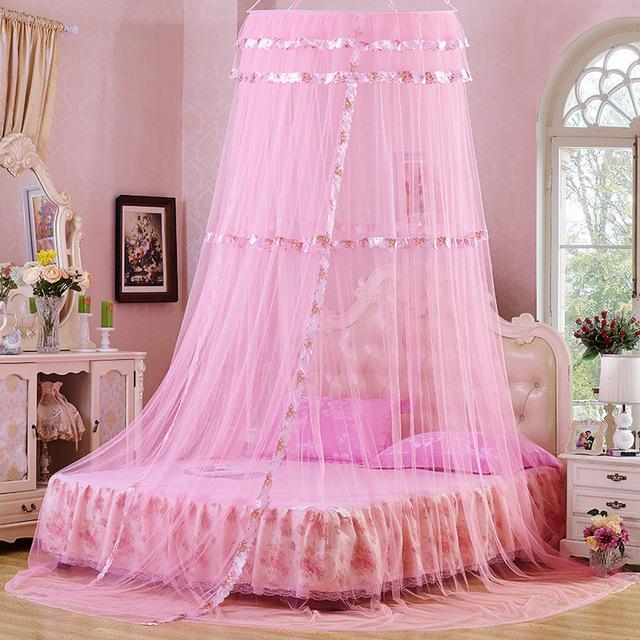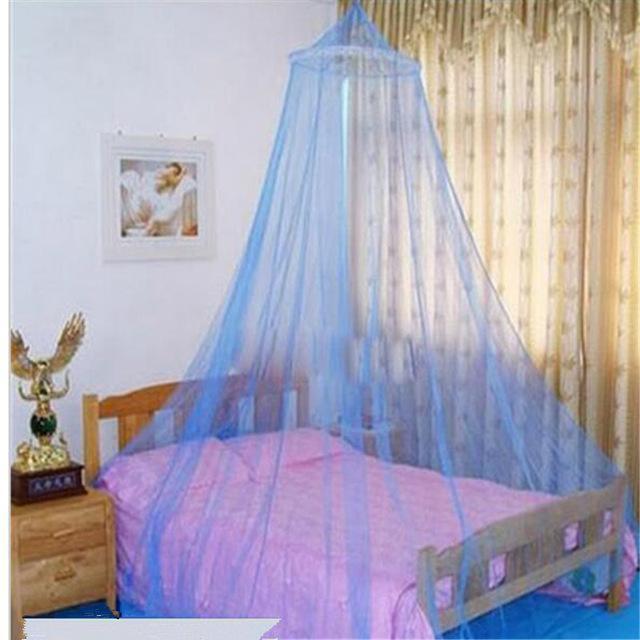The first image is the image on the left, the second image is the image on the right. Given the left and right images, does the statement "Each image shows a gauzy canopy that drapes from a round shape suspended from the ceiling, but the left image features a white canopy while the right image features an off-white canopy." hold true? Answer yes or no. No. 